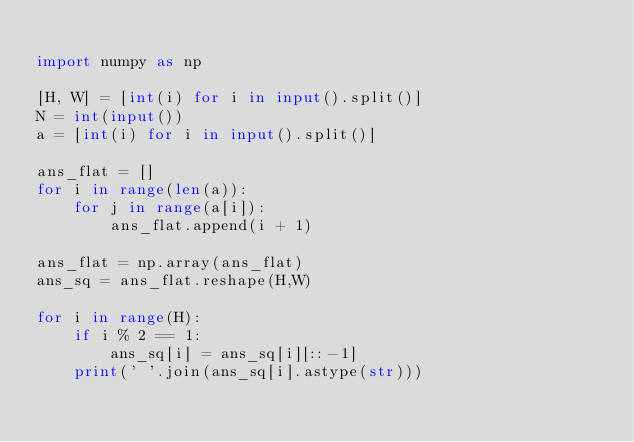Convert code to text. <code><loc_0><loc_0><loc_500><loc_500><_Python_>
import numpy as np

[H, W] = [int(i) for i in input().split()]
N = int(input())
a = [int(i) for i in input().split()]

ans_flat = []
for i in range(len(a)):
    for j in range(a[i]):
        ans_flat.append(i + 1)

ans_flat = np.array(ans_flat)
ans_sq = ans_flat.reshape(H,W)

for i in range(H):
    if i % 2 == 1:
        ans_sq[i] = ans_sq[i][::-1]
    print(' '.join(ans_sq[i].astype(str)))

</code> 